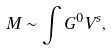Convert formula to latex. <formula><loc_0><loc_0><loc_500><loc_500>M \sim \int G ^ { 0 } V ^ { s } ,</formula> 